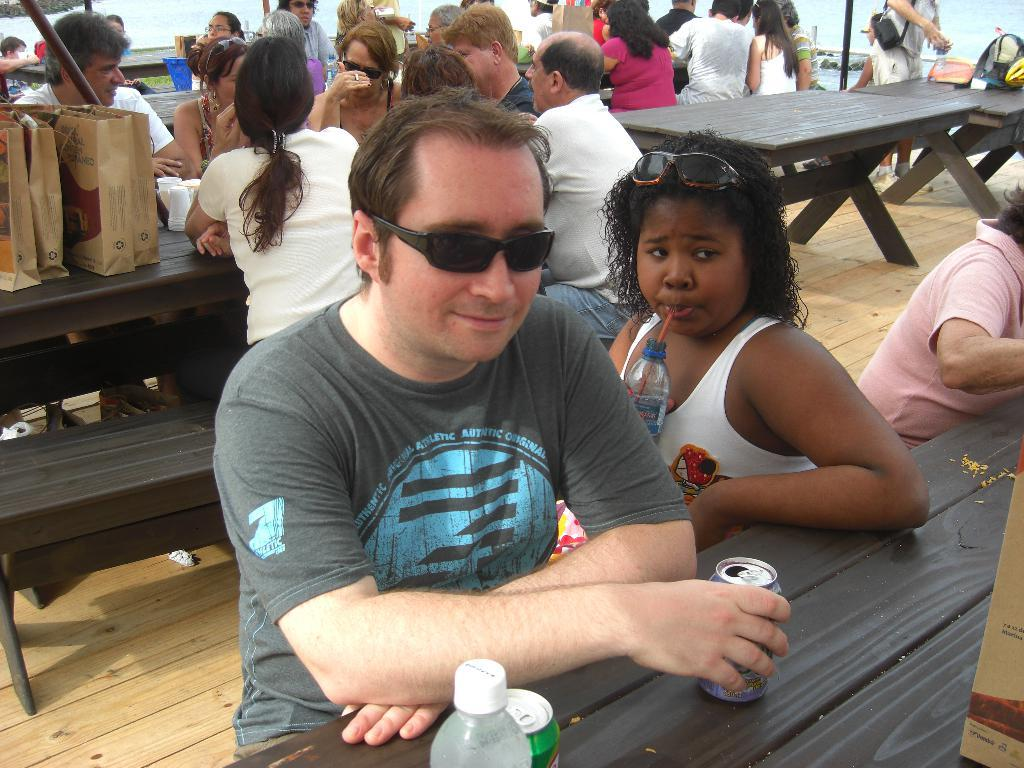What are the majority of people in the image doing? Most of the persons are sitting on a bench. What objects can be seen on the table in the image? There are bags, cups, tins, and a bottle on the table. Can you describe the appearance of one of the persons in the image? A man is wearing goggles. What type of meat can be seen cooking in the field in the image? There is no meat or field present in the image. How hot is the environment in the image? The image does not provide information about the temperature or heat in the environment. 